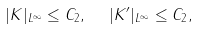<formula> <loc_0><loc_0><loc_500><loc_500>| K | _ { L ^ { \infty } } \leq C _ { 2 } , \ \ | K ^ { \prime } | _ { L ^ { \infty } } \leq C _ { 2 } ,</formula> 